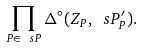<formula> <loc_0><loc_0><loc_500><loc_500>\prod _ { P \in \ s P } \Delta ^ { \circ } ( Z _ { P } , \ s P ^ { \prime } _ { P } ) .</formula> 